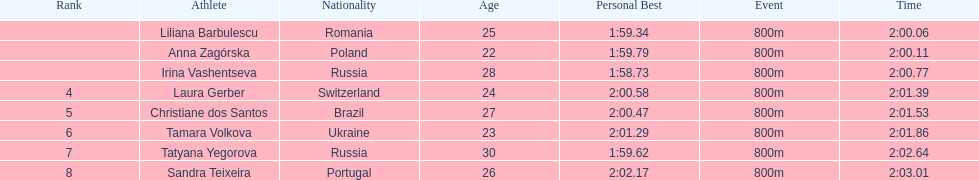What was the time difference between the first place finisher and the eighth place finisher? 2.95. 